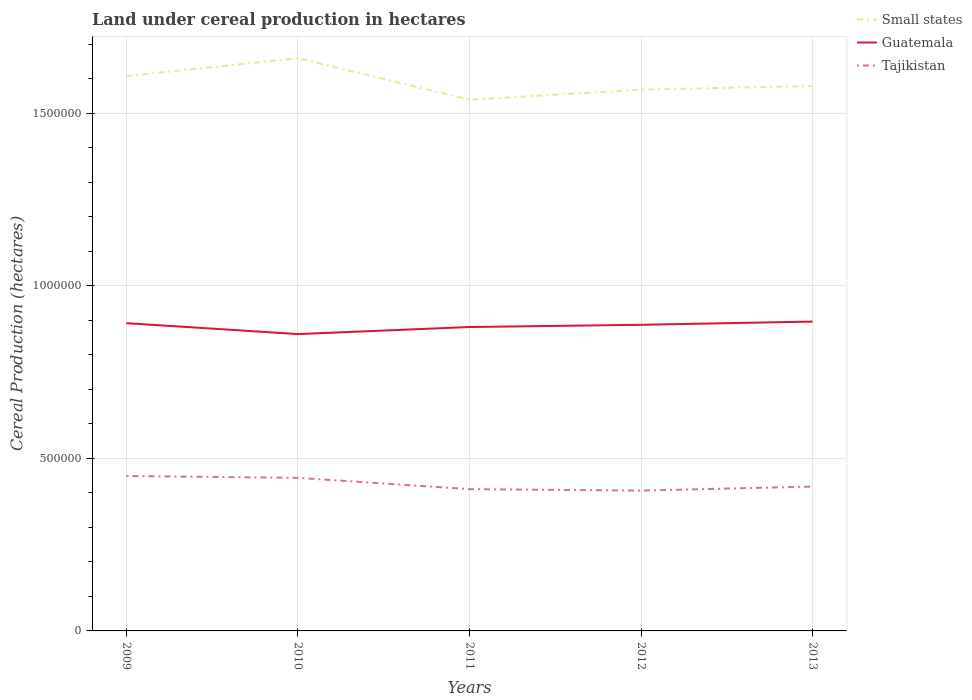How many different coloured lines are there?
Give a very brief answer. 3. Is the number of lines equal to the number of legend labels?
Keep it short and to the point. Yes. Across all years, what is the maximum land under cereal production in Guatemala?
Your answer should be very brief. 8.60e+05. What is the total land under cereal production in Tajikistan in the graph?
Your answer should be very brief. 3.28e+04. What is the difference between the highest and the second highest land under cereal production in Guatemala?
Offer a very short reply. 3.63e+04. How many lines are there?
Your answer should be compact. 3. What is the difference between two consecutive major ticks on the Y-axis?
Your response must be concise. 5.00e+05. Does the graph contain grids?
Your response must be concise. Yes. How many legend labels are there?
Provide a short and direct response. 3. How are the legend labels stacked?
Provide a succinct answer. Vertical. What is the title of the graph?
Ensure brevity in your answer.  Land under cereal production in hectares. What is the label or title of the Y-axis?
Your response must be concise. Cereal Production (hectares). What is the Cereal Production (hectares) in Small states in 2009?
Ensure brevity in your answer.  1.61e+06. What is the Cereal Production (hectares) of Guatemala in 2009?
Provide a succinct answer. 8.92e+05. What is the Cereal Production (hectares) of Tajikistan in 2009?
Your answer should be compact. 4.49e+05. What is the Cereal Production (hectares) in Small states in 2010?
Your answer should be compact. 1.66e+06. What is the Cereal Production (hectares) in Guatemala in 2010?
Offer a very short reply. 8.60e+05. What is the Cereal Production (hectares) of Tajikistan in 2010?
Your answer should be compact. 4.44e+05. What is the Cereal Production (hectares) in Small states in 2011?
Keep it short and to the point. 1.54e+06. What is the Cereal Production (hectares) in Guatemala in 2011?
Ensure brevity in your answer.  8.80e+05. What is the Cereal Production (hectares) of Tajikistan in 2011?
Offer a terse response. 4.11e+05. What is the Cereal Production (hectares) in Small states in 2012?
Your response must be concise. 1.57e+06. What is the Cereal Production (hectares) in Guatemala in 2012?
Provide a succinct answer. 8.87e+05. What is the Cereal Production (hectares) of Tajikistan in 2012?
Your answer should be compact. 4.07e+05. What is the Cereal Production (hectares) of Small states in 2013?
Make the answer very short. 1.58e+06. What is the Cereal Production (hectares) of Guatemala in 2013?
Keep it short and to the point. 8.96e+05. What is the Cereal Production (hectares) of Tajikistan in 2013?
Provide a short and direct response. 4.18e+05. Across all years, what is the maximum Cereal Production (hectares) of Small states?
Your answer should be very brief. 1.66e+06. Across all years, what is the maximum Cereal Production (hectares) of Guatemala?
Make the answer very short. 8.96e+05. Across all years, what is the maximum Cereal Production (hectares) of Tajikistan?
Give a very brief answer. 4.49e+05. Across all years, what is the minimum Cereal Production (hectares) of Small states?
Provide a short and direct response. 1.54e+06. Across all years, what is the minimum Cereal Production (hectares) of Guatemala?
Offer a very short reply. 8.60e+05. Across all years, what is the minimum Cereal Production (hectares) of Tajikistan?
Provide a succinct answer. 4.07e+05. What is the total Cereal Production (hectares) of Small states in the graph?
Make the answer very short. 7.95e+06. What is the total Cereal Production (hectares) in Guatemala in the graph?
Ensure brevity in your answer.  4.42e+06. What is the total Cereal Production (hectares) of Tajikistan in the graph?
Provide a succinct answer. 2.13e+06. What is the difference between the Cereal Production (hectares) of Small states in 2009 and that in 2010?
Provide a succinct answer. -5.18e+04. What is the difference between the Cereal Production (hectares) in Guatemala in 2009 and that in 2010?
Provide a succinct answer. 3.16e+04. What is the difference between the Cereal Production (hectares) of Tajikistan in 2009 and that in 2010?
Make the answer very short. 5244.7. What is the difference between the Cereal Production (hectares) of Small states in 2009 and that in 2011?
Your response must be concise. 6.86e+04. What is the difference between the Cereal Production (hectares) in Guatemala in 2009 and that in 2011?
Your response must be concise. 1.12e+04. What is the difference between the Cereal Production (hectares) in Tajikistan in 2009 and that in 2011?
Your answer should be compact. 3.80e+04. What is the difference between the Cereal Production (hectares) in Small states in 2009 and that in 2012?
Your answer should be very brief. 3.94e+04. What is the difference between the Cereal Production (hectares) of Guatemala in 2009 and that in 2012?
Keep it short and to the point. 4709. What is the difference between the Cereal Production (hectares) in Tajikistan in 2009 and that in 2012?
Make the answer very short. 4.22e+04. What is the difference between the Cereal Production (hectares) in Small states in 2009 and that in 2013?
Make the answer very short. 2.88e+04. What is the difference between the Cereal Production (hectares) in Guatemala in 2009 and that in 2013?
Your answer should be compact. -4671. What is the difference between the Cereal Production (hectares) in Tajikistan in 2009 and that in 2013?
Your answer should be compact. 3.05e+04. What is the difference between the Cereal Production (hectares) in Small states in 2010 and that in 2011?
Give a very brief answer. 1.20e+05. What is the difference between the Cereal Production (hectares) in Guatemala in 2010 and that in 2011?
Your response must be concise. -2.04e+04. What is the difference between the Cereal Production (hectares) of Tajikistan in 2010 and that in 2011?
Your response must be concise. 3.28e+04. What is the difference between the Cereal Production (hectares) of Small states in 2010 and that in 2012?
Offer a very short reply. 9.12e+04. What is the difference between the Cereal Production (hectares) of Guatemala in 2010 and that in 2012?
Your response must be concise. -2.69e+04. What is the difference between the Cereal Production (hectares) in Tajikistan in 2010 and that in 2012?
Ensure brevity in your answer.  3.69e+04. What is the difference between the Cereal Production (hectares) of Small states in 2010 and that in 2013?
Keep it short and to the point. 8.06e+04. What is the difference between the Cereal Production (hectares) of Guatemala in 2010 and that in 2013?
Keep it short and to the point. -3.63e+04. What is the difference between the Cereal Production (hectares) of Tajikistan in 2010 and that in 2013?
Make the answer very short. 2.53e+04. What is the difference between the Cereal Production (hectares) of Small states in 2011 and that in 2012?
Offer a terse response. -2.92e+04. What is the difference between the Cereal Production (hectares) of Guatemala in 2011 and that in 2012?
Keep it short and to the point. -6484. What is the difference between the Cereal Production (hectares) of Tajikistan in 2011 and that in 2012?
Provide a succinct answer. 4181. What is the difference between the Cereal Production (hectares) in Small states in 2011 and that in 2013?
Your answer should be compact. -3.98e+04. What is the difference between the Cereal Production (hectares) in Guatemala in 2011 and that in 2013?
Your answer should be compact. -1.59e+04. What is the difference between the Cereal Production (hectares) of Tajikistan in 2011 and that in 2013?
Your answer should be very brief. -7466. What is the difference between the Cereal Production (hectares) of Small states in 2012 and that in 2013?
Offer a terse response. -1.06e+04. What is the difference between the Cereal Production (hectares) of Guatemala in 2012 and that in 2013?
Your answer should be very brief. -9380. What is the difference between the Cereal Production (hectares) of Tajikistan in 2012 and that in 2013?
Make the answer very short. -1.16e+04. What is the difference between the Cereal Production (hectares) of Small states in 2009 and the Cereal Production (hectares) of Guatemala in 2010?
Provide a short and direct response. 7.47e+05. What is the difference between the Cereal Production (hectares) of Small states in 2009 and the Cereal Production (hectares) of Tajikistan in 2010?
Offer a terse response. 1.16e+06. What is the difference between the Cereal Production (hectares) of Guatemala in 2009 and the Cereal Production (hectares) of Tajikistan in 2010?
Provide a short and direct response. 4.48e+05. What is the difference between the Cereal Production (hectares) of Small states in 2009 and the Cereal Production (hectares) of Guatemala in 2011?
Give a very brief answer. 7.27e+05. What is the difference between the Cereal Production (hectares) in Small states in 2009 and the Cereal Production (hectares) in Tajikistan in 2011?
Provide a short and direct response. 1.20e+06. What is the difference between the Cereal Production (hectares) of Guatemala in 2009 and the Cereal Production (hectares) of Tajikistan in 2011?
Your response must be concise. 4.81e+05. What is the difference between the Cereal Production (hectares) of Small states in 2009 and the Cereal Production (hectares) of Guatemala in 2012?
Give a very brief answer. 7.21e+05. What is the difference between the Cereal Production (hectares) of Small states in 2009 and the Cereal Production (hectares) of Tajikistan in 2012?
Ensure brevity in your answer.  1.20e+06. What is the difference between the Cereal Production (hectares) in Guatemala in 2009 and the Cereal Production (hectares) in Tajikistan in 2012?
Make the answer very short. 4.85e+05. What is the difference between the Cereal Production (hectares) in Small states in 2009 and the Cereal Production (hectares) in Guatemala in 2013?
Offer a terse response. 7.11e+05. What is the difference between the Cereal Production (hectares) of Small states in 2009 and the Cereal Production (hectares) of Tajikistan in 2013?
Keep it short and to the point. 1.19e+06. What is the difference between the Cereal Production (hectares) of Guatemala in 2009 and the Cereal Production (hectares) of Tajikistan in 2013?
Your response must be concise. 4.73e+05. What is the difference between the Cereal Production (hectares) of Small states in 2010 and the Cereal Production (hectares) of Guatemala in 2011?
Provide a succinct answer. 7.79e+05. What is the difference between the Cereal Production (hectares) in Small states in 2010 and the Cereal Production (hectares) in Tajikistan in 2011?
Ensure brevity in your answer.  1.25e+06. What is the difference between the Cereal Production (hectares) of Guatemala in 2010 and the Cereal Production (hectares) of Tajikistan in 2011?
Provide a short and direct response. 4.49e+05. What is the difference between the Cereal Production (hectares) in Small states in 2010 and the Cereal Production (hectares) in Guatemala in 2012?
Your response must be concise. 7.72e+05. What is the difference between the Cereal Production (hectares) of Small states in 2010 and the Cereal Production (hectares) of Tajikistan in 2012?
Provide a succinct answer. 1.25e+06. What is the difference between the Cereal Production (hectares) of Guatemala in 2010 and the Cereal Production (hectares) of Tajikistan in 2012?
Your answer should be very brief. 4.53e+05. What is the difference between the Cereal Production (hectares) in Small states in 2010 and the Cereal Production (hectares) in Guatemala in 2013?
Your answer should be very brief. 7.63e+05. What is the difference between the Cereal Production (hectares) in Small states in 2010 and the Cereal Production (hectares) in Tajikistan in 2013?
Offer a very short reply. 1.24e+06. What is the difference between the Cereal Production (hectares) in Guatemala in 2010 and the Cereal Production (hectares) in Tajikistan in 2013?
Provide a short and direct response. 4.42e+05. What is the difference between the Cereal Production (hectares) in Small states in 2011 and the Cereal Production (hectares) in Guatemala in 2012?
Your response must be concise. 6.52e+05. What is the difference between the Cereal Production (hectares) of Small states in 2011 and the Cereal Production (hectares) of Tajikistan in 2012?
Provide a short and direct response. 1.13e+06. What is the difference between the Cereal Production (hectares) of Guatemala in 2011 and the Cereal Production (hectares) of Tajikistan in 2012?
Your answer should be very brief. 4.74e+05. What is the difference between the Cereal Production (hectares) of Small states in 2011 and the Cereal Production (hectares) of Guatemala in 2013?
Offer a terse response. 6.43e+05. What is the difference between the Cereal Production (hectares) of Small states in 2011 and the Cereal Production (hectares) of Tajikistan in 2013?
Your answer should be very brief. 1.12e+06. What is the difference between the Cereal Production (hectares) of Guatemala in 2011 and the Cereal Production (hectares) of Tajikistan in 2013?
Give a very brief answer. 4.62e+05. What is the difference between the Cereal Production (hectares) of Small states in 2012 and the Cereal Production (hectares) of Guatemala in 2013?
Make the answer very short. 6.72e+05. What is the difference between the Cereal Production (hectares) of Small states in 2012 and the Cereal Production (hectares) of Tajikistan in 2013?
Ensure brevity in your answer.  1.15e+06. What is the difference between the Cereal Production (hectares) in Guatemala in 2012 and the Cereal Production (hectares) in Tajikistan in 2013?
Your response must be concise. 4.69e+05. What is the average Cereal Production (hectares) in Small states per year?
Your answer should be very brief. 1.59e+06. What is the average Cereal Production (hectares) of Guatemala per year?
Provide a succinct answer. 8.83e+05. What is the average Cereal Production (hectares) in Tajikistan per year?
Make the answer very short. 4.26e+05. In the year 2009, what is the difference between the Cereal Production (hectares) of Small states and Cereal Production (hectares) of Guatemala?
Offer a terse response. 7.16e+05. In the year 2009, what is the difference between the Cereal Production (hectares) in Small states and Cereal Production (hectares) in Tajikistan?
Your answer should be compact. 1.16e+06. In the year 2009, what is the difference between the Cereal Production (hectares) of Guatemala and Cereal Production (hectares) of Tajikistan?
Provide a short and direct response. 4.43e+05. In the year 2010, what is the difference between the Cereal Production (hectares) in Small states and Cereal Production (hectares) in Guatemala?
Give a very brief answer. 7.99e+05. In the year 2010, what is the difference between the Cereal Production (hectares) of Small states and Cereal Production (hectares) of Tajikistan?
Your response must be concise. 1.22e+06. In the year 2010, what is the difference between the Cereal Production (hectares) of Guatemala and Cereal Production (hectares) of Tajikistan?
Give a very brief answer. 4.17e+05. In the year 2011, what is the difference between the Cereal Production (hectares) of Small states and Cereal Production (hectares) of Guatemala?
Your answer should be compact. 6.58e+05. In the year 2011, what is the difference between the Cereal Production (hectares) in Small states and Cereal Production (hectares) in Tajikistan?
Provide a short and direct response. 1.13e+06. In the year 2011, what is the difference between the Cereal Production (hectares) of Guatemala and Cereal Production (hectares) of Tajikistan?
Keep it short and to the point. 4.70e+05. In the year 2012, what is the difference between the Cereal Production (hectares) in Small states and Cereal Production (hectares) in Guatemala?
Offer a very short reply. 6.81e+05. In the year 2012, what is the difference between the Cereal Production (hectares) in Small states and Cereal Production (hectares) in Tajikistan?
Your answer should be very brief. 1.16e+06. In the year 2012, what is the difference between the Cereal Production (hectares) in Guatemala and Cereal Production (hectares) in Tajikistan?
Your response must be concise. 4.80e+05. In the year 2013, what is the difference between the Cereal Production (hectares) of Small states and Cereal Production (hectares) of Guatemala?
Your answer should be very brief. 6.82e+05. In the year 2013, what is the difference between the Cereal Production (hectares) in Small states and Cereal Production (hectares) in Tajikistan?
Ensure brevity in your answer.  1.16e+06. In the year 2013, what is the difference between the Cereal Production (hectares) in Guatemala and Cereal Production (hectares) in Tajikistan?
Your answer should be compact. 4.78e+05. What is the ratio of the Cereal Production (hectares) of Small states in 2009 to that in 2010?
Offer a very short reply. 0.97. What is the ratio of the Cereal Production (hectares) of Guatemala in 2009 to that in 2010?
Keep it short and to the point. 1.04. What is the ratio of the Cereal Production (hectares) in Tajikistan in 2009 to that in 2010?
Your answer should be compact. 1.01. What is the ratio of the Cereal Production (hectares) of Small states in 2009 to that in 2011?
Make the answer very short. 1.04. What is the ratio of the Cereal Production (hectares) of Guatemala in 2009 to that in 2011?
Your answer should be compact. 1.01. What is the ratio of the Cereal Production (hectares) in Tajikistan in 2009 to that in 2011?
Provide a succinct answer. 1.09. What is the ratio of the Cereal Production (hectares) of Small states in 2009 to that in 2012?
Ensure brevity in your answer.  1.03. What is the ratio of the Cereal Production (hectares) in Tajikistan in 2009 to that in 2012?
Provide a succinct answer. 1.1. What is the ratio of the Cereal Production (hectares) of Small states in 2009 to that in 2013?
Keep it short and to the point. 1.02. What is the ratio of the Cereal Production (hectares) in Tajikistan in 2009 to that in 2013?
Give a very brief answer. 1.07. What is the ratio of the Cereal Production (hectares) of Small states in 2010 to that in 2011?
Offer a terse response. 1.08. What is the ratio of the Cereal Production (hectares) of Guatemala in 2010 to that in 2011?
Offer a terse response. 0.98. What is the ratio of the Cereal Production (hectares) in Tajikistan in 2010 to that in 2011?
Offer a very short reply. 1.08. What is the ratio of the Cereal Production (hectares) in Small states in 2010 to that in 2012?
Ensure brevity in your answer.  1.06. What is the ratio of the Cereal Production (hectares) in Guatemala in 2010 to that in 2012?
Ensure brevity in your answer.  0.97. What is the ratio of the Cereal Production (hectares) of Small states in 2010 to that in 2013?
Ensure brevity in your answer.  1.05. What is the ratio of the Cereal Production (hectares) of Guatemala in 2010 to that in 2013?
Ensure brevity in your answer.  0.96. What is the ratio of the Cereal Production (hectares) of Tajikistan in 2010 to that in 2013?
Make the answer very short. 1.06. What is the ratio of the Cereal Production (hectares) in Small states in 2011 to that in 2012?
Ensure brevity in your answer.  0.98. What is the ratio of the Cereal Production (hectares) of Guatemala in 2011 to that in 2012?
Ensure brevity in your answer.  0.99. What is the ratio of the Cereal Production (hectares) of Tajikistan in 2011 to that in 2012?
Keep it short and to the point. 1.01. What is the ratio of the Cereal Production (hectares) in Small states in 2011 to that in 2013?
Make the answer very short. 0.97. What is the ratio of the Cereal Production (hectares) of Guatemala in 2011 to that in 2013?
Your answer should be compact. 0.98. What is the ratio of the Cereal Production (hectares) of Tajikistan in 2011 to that in 2013?
Your answer should be very brief. 0.98. What is the ratio of the Cereal Production (hectares) in Tajikistan in 2012 to that in 2013?
Your answer should be compact. 0.97. What is the difference between the highest and the second highest Cereal Production (hectares) of Small states?
Your answer should be very brief. 5.18e+04. What is the difference between the highest and the second highest Cereal Production (hectares) of Guatemala?
Give a very brief answer. 4671. What is the difference between the highest and the second highest Cereal Production (hectares) in Tajikistan?
Give a very brief answer. 5244.7. What is the difference between the highest and the lowest Cereal Production (hectares) in Small states?
Your answer should be compact. 1.20e+05. What is the difference between the highest and the lowest Cereal Production (hectares) of Guatemala?
Offer a very short reply. 3.63e+04. What is the difference between the highest and the lowest Cereal Production (hectares) of Tajikistan?
Offer a terse response. 4.22e+04. 